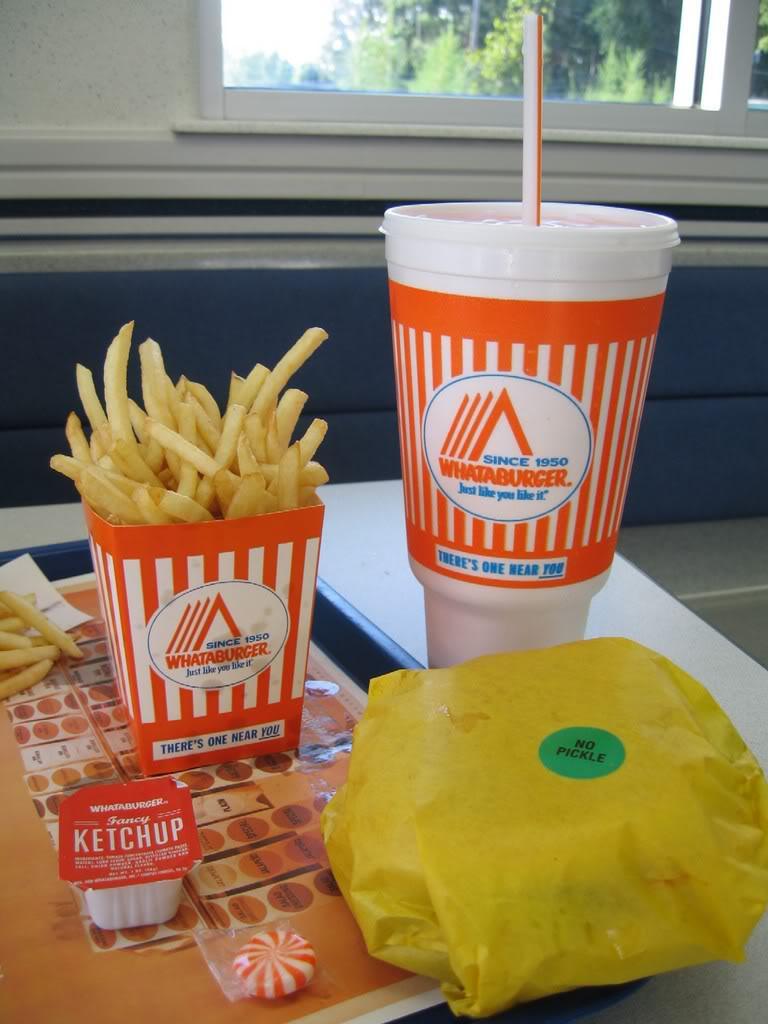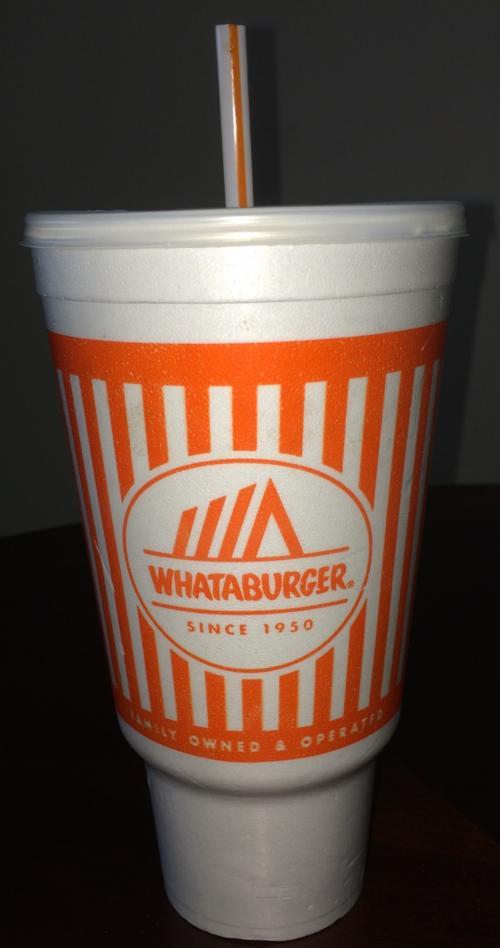The first image is the image on the left, the second image is the image on the right. Evaluate the accuracy of this statement regarding the images: "The right image shows a """"Whataburger"""" cup sitting on a surface.". Is it true? Answer yes or no. Yes. The first image is the image on the left, the second image is the image on the right. Examine the images to the left and right. Is the description "There are two large orange and white cups sitting directly on a table." accurate? Answer yes or no. Yes. 